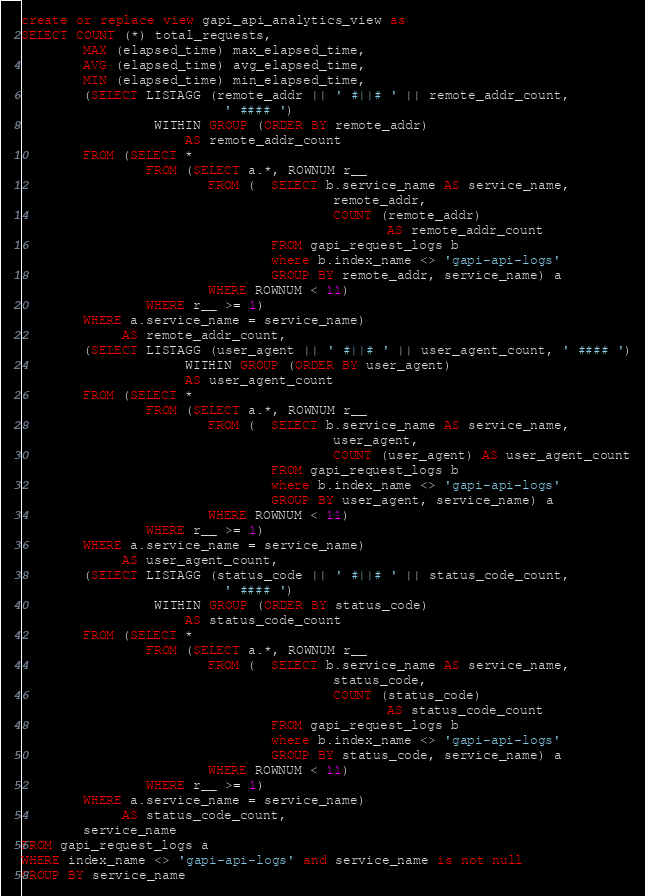Convert code to text. <code><loc_0><loc_0><loc_500><loc_500><_SQL_>create or replace view gapi_api_analytics_view as
SELECT COUNT (*) total_requests,
        MAX (elapsed_time) max_elapsed_time,
        AVG (elapsed_time) avg_elapsed_time,
        MIN (elapsed_time) min_elapsed_time,
        (SELECT LISTAGG (remote_addr || ' #||# ' || remote_addr_count,
                          ' #### ')
                 WITHIN GROUP (ORDER BY remote_addr)
                     AS remote_addr_count
        FROM (SELECT *
                FROM (SELECT a.*, ROWNUM r__
                        FROM (  SELECT b.service_name AS service_name,
                                        remote_addr,
                                        COUNT (remote_addr)
                                               AS remote_addr_count
                                FROM gapi_request_logs b
                                where b.index_name <> 'gapi-api-logs'
                                GROUP BY remote_addr, service_name) a
                        WHERE ROWNUM < 11)
                WHERE r__ >= 1)
        WHERE a.service_name = service_name)
             AS remote_addr_count,
        (SELECT LISTAGG (user_agent || ' #||# ' || user_agent_count, ' #### ')
                     WITHIN GROUP (ORDER BY user_agent)
                     AS user_agent_count
        FROM (SELECT *
                FROM (SELECT a.*, ROWNUM r__
                        FROM (  SELECT b.service_name AS service_name,
                                        user_agent,
                                        COUNT (user_agent) AS user_agent_count
                                FROM gapi_request_logs b
                                where b.index_name <> 'gapi-api-logs'
                                GROUP BY user_agent, service_name) a
                        WHERE ROWNUM < 11)
                WHERE r__ >= 1)
        WHERE a.service_name = service_name)
             AS user_agent_count,
        (SELECT LISTAGG (status_code || ' #||# ' || status_code_count,
                          ' #### ')
                 WITHIN GROUP (ORDER BY status_code)
                     AS status_code_count
        FROM (SELECT *
                FROM (SELECT a.*, ROWNUM r__
                        FROM (  SELECT b.service_name AS service_name,
                                        status_code,
                                        COUNT (status_code)
                                               AS status_code_count
                                FROM gapi_request_logs b
                                where b.index_name <> 'gapi-api-logs'
                                GROUP BY status_code, service_name) a
                        WHERE ROWNUM < 11)
                WHERE r__ >= 1)
        WHERE a.service_name = service_name)
             AS status_code_count,
        service_name
FROM gapi_request_logs a
WHERE index_name <> 'gapi-api-logs' and service_name is not null
GROUP BY service_name</code> 